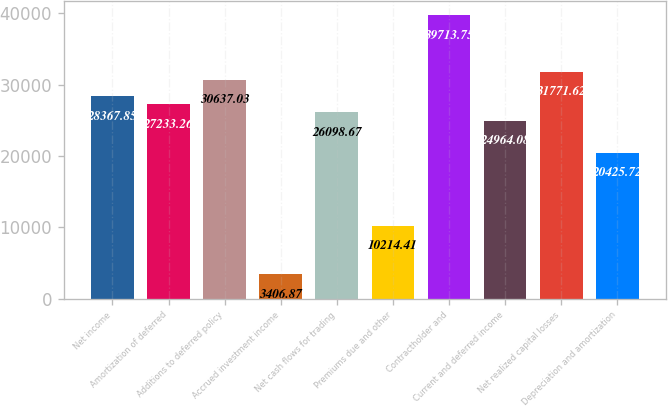<chart> <loc_0><loc_0><loc_500><loc_500><bar_chart><fcel>Net income<fcel>Amortization of deferred<fcel>Additions to deferred policy<fcel>Accrued investment income<fcel>Net cash flows for trading<fcel>Premiums due and other<fcel>Contractholder and<fcel>Current and deferred income<fcel>Net realized capital losses<fcel>Depreciation and amortization<nl><fcel>28367.8<fcel>27233.3<fcel>30637<fcel>3406.87<fcel>26098.7<fcel>10214.4<fcel>39713.8<fcel>24964.1<fcel>31771.6<fcel>20425.7<nl></chart> 